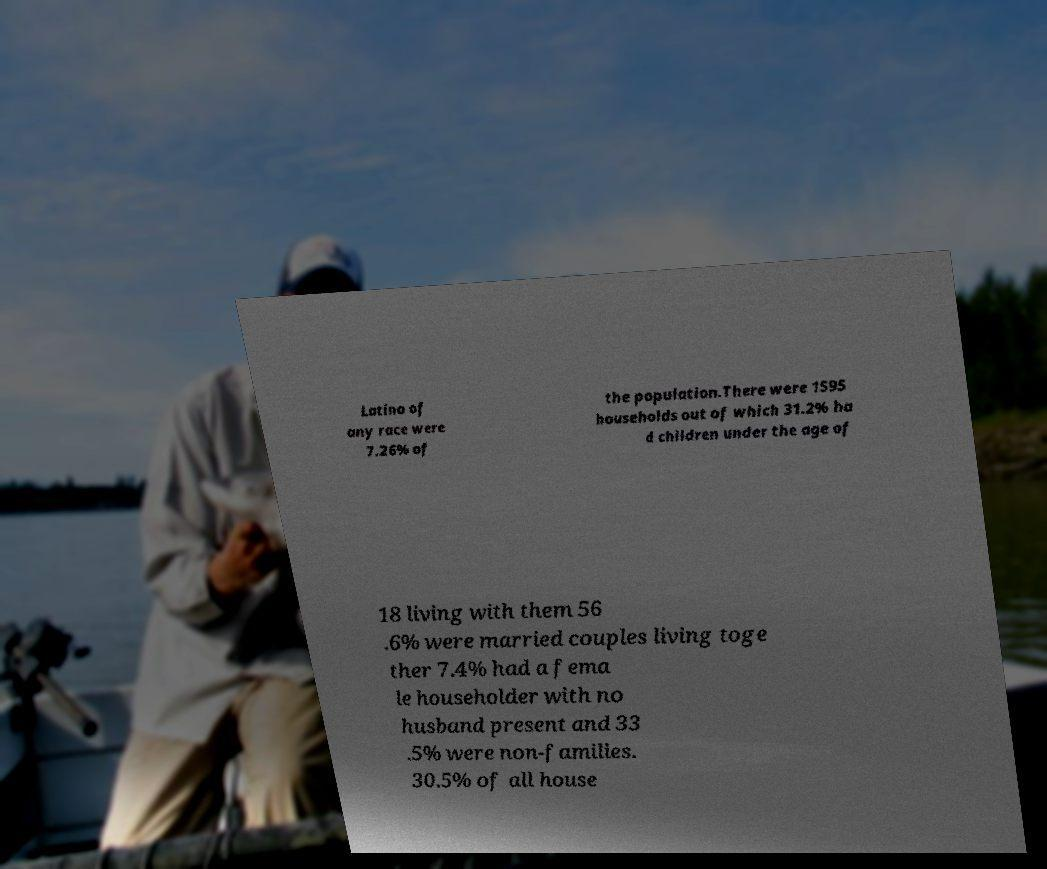Can you read and provide the text displayed in the image?This photo seems to have some interesting text. Can you extract and type it out for me? Latino of any race were 7.26% of the population.There were 1595 households out of which 31.2% ha d children under the age of 18 living with them 56 .6% were married couples living toge ther 7.4% had a fema le householder with no husband present and 33 .5% were non-families. 30.5% of all house 